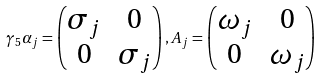<formula> <loc_0><loc_0><loc_500><loc_500>\gamma _ { 5 } \alpha _ { j } = \begin{pmatrix} \sigma _ { j } & 0 \\ 0 & \sigma _ { j } \end{pmatrix} , A _ { j } = \begin{pmatrix} \omega _ { j } & 0 \\ 0 & \omega _ { j } \end{pmatrix}</formula> 